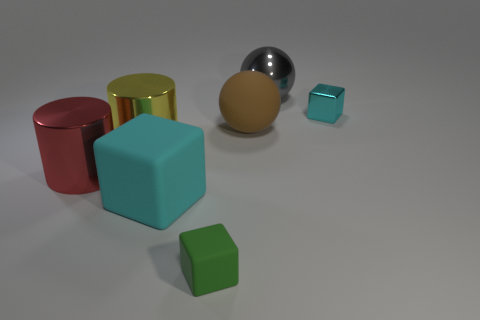Is there a pattern in the arrangement of the objects? The objects seem to be arranged by size and reflectiveness. The larger, colorful objects are grouped together, while the smaller, shinier objects are placed farther back. This could suggest a deliberate contrast between the objects' sizes and textures. 